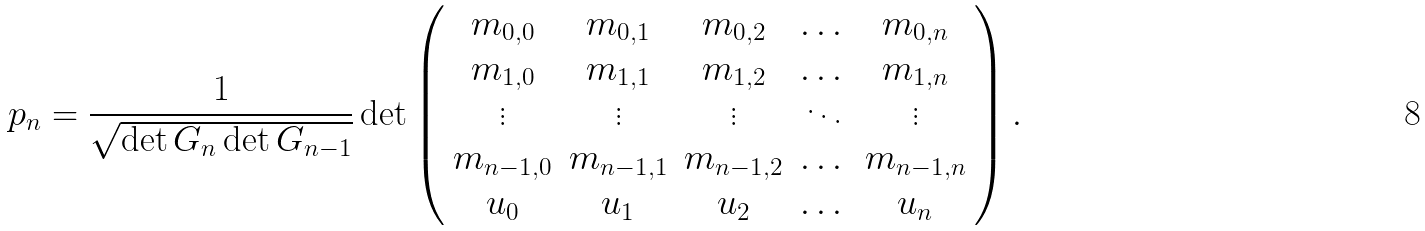Convert formula to latex. <formula><loc_0><loc_0><loc_500><loc_500>p _ { n } & = \frac { 1 } { \sqrt { \det G _ { n } \det G _ { n - 1 } } } \det \left ( \begin{array} { c c c c c } m _ { 0 , 0 } & m _ { 0 , 1 } & m _ { 0 , 2 } & \dots & m _ { 0 , n } \\ m _ { 1 , 0 } & m _ { 1 , 1 } & m _ { 1 , 2 } & \dots & m _ { 1 , n } \\ \vdots & \vdots & \vdots & \ddots & \vdots \\ m _ { n - 1 , 0 } & m _ { n - 1 , 1 } & m _ { n - 1 , 2 } & \dots & m _ { n - 1 , n } \\ u _ { 0 } & u _ { 1 } & u _ { 2 } & \dots & u _ { n } \end{array} \right ) .</formula> 